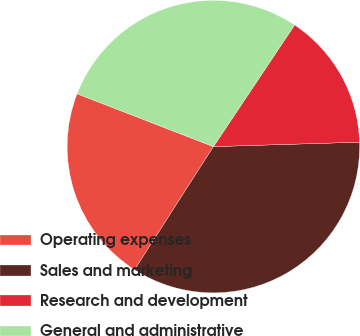<chart> <loc_0><loc_0><loc_500><loc_500><pie_chart><fcel>Operating expenses<fcel>Sales and marketing<fcel>Research and development<fcel>General and administrative<nl><fcel>21.82%<fcel>34.55%<fcel>15.15%<fcel>28.48%<nl></chart> 